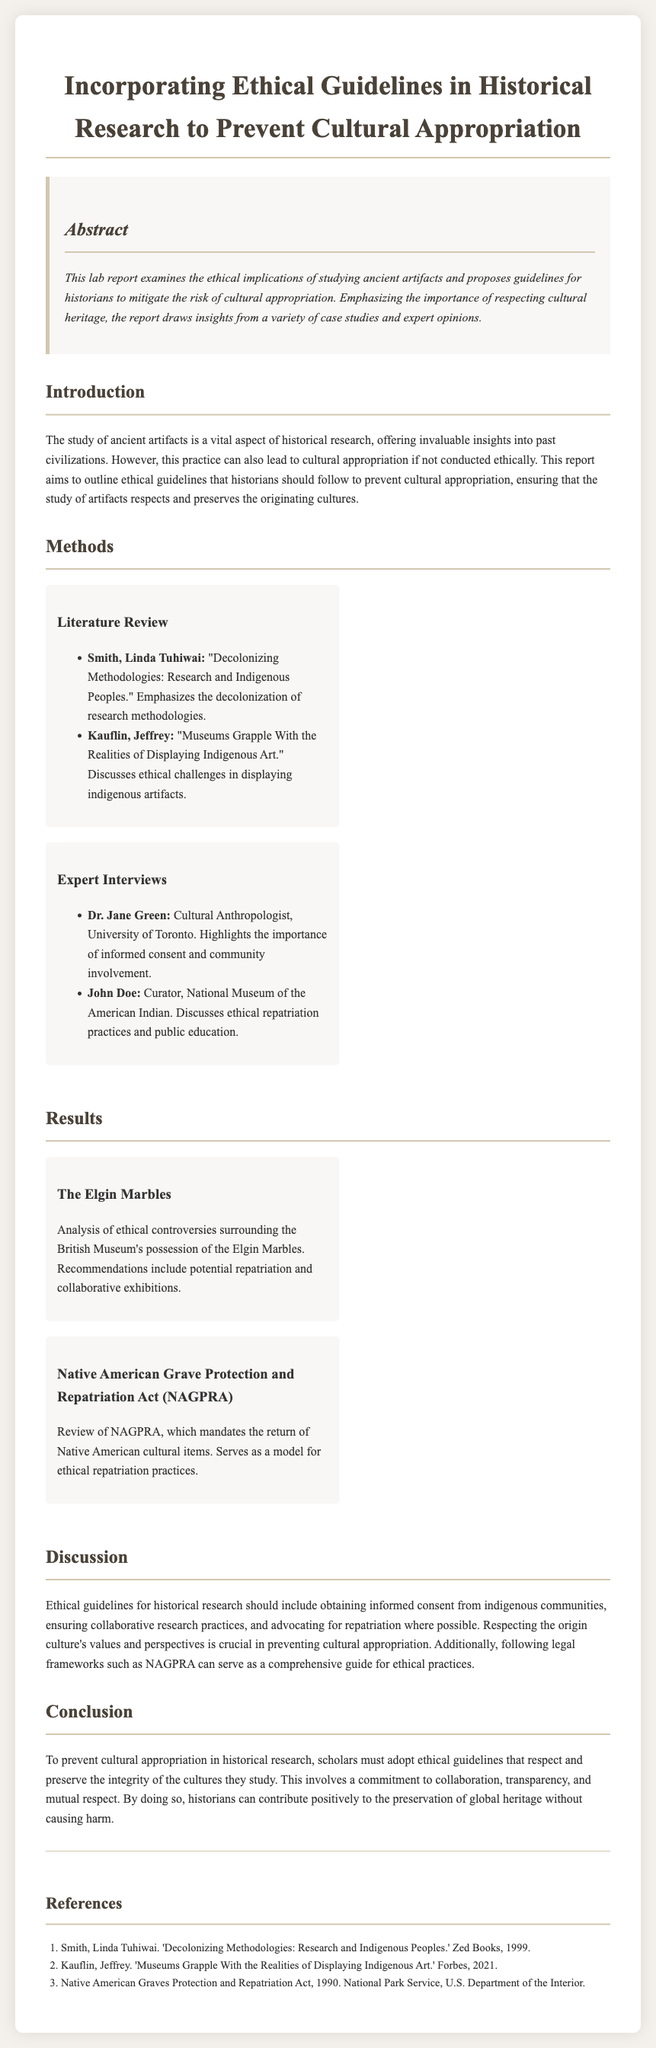What is the title of the lab report? The title of the lab report is given in the header section, summarizing the main focus of the document.
Answer: Incorporating Ethical Guidelines in Historical Research to Prevent Cultural Appropriation Who is the author of "Decolonizing Methodologies: Research and Indigenous Peoples"? This information is found in the literature review section, listing significant works in the field.
Answer: Linda Tuhiwai Smith What year was the Native American Graves Protection and Repatriation Act enacted? The act's year is mentioned in the references section as part of its citation.
Answer: 1990 What ethical guideline involves working with indigenous communities? This guideline is discussed in the discussion section, highlighting essential ethical considerations in historical research.
Answer: Informed consent What case study discusses potential repatriation of artifacts? The case studies section provides examples of ethical controversies in artifact possession, including discussions about repatriation.
Answer: The Elgin Marbles Which institution's curator discusses ethical repatriation practices? This information can be found in the expert interviews section, detailing who the experts are and their affiliations.
Answer: National Museum of the American Indian What is the main focus of the abstract? The abstract summarizes the ethical implications of studying ancient artifacts and the proposed guidelines.
Answer: Ethical implications of studying ancient artifacts How many case studies are mentioned in the document? The results section lists the number of specific case studies included in the analysis.
Answer: Two 